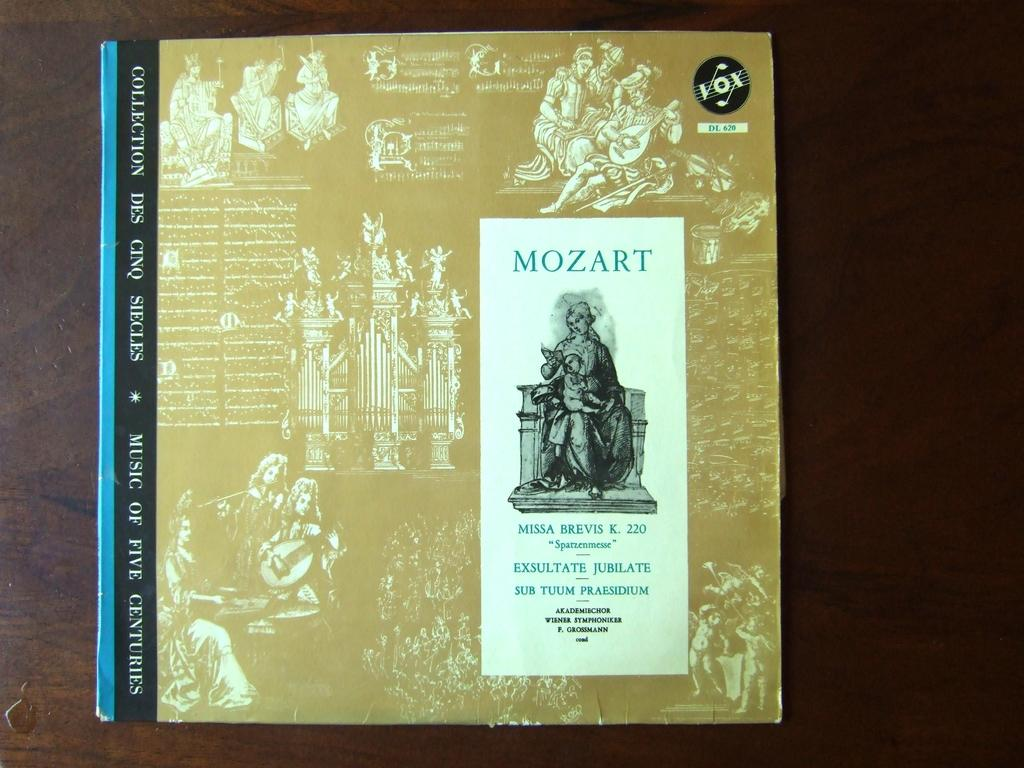<image>
Give a short and clear explanation of the subsequent image. Mozart Missa Brevis K 220 music player record 